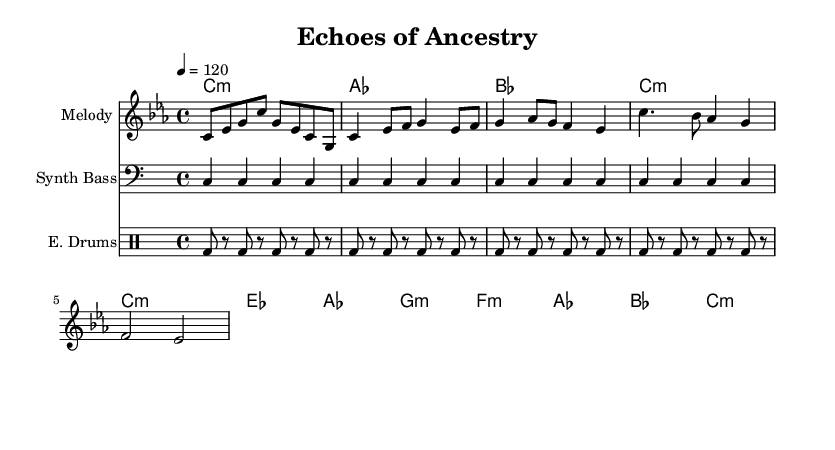What is the key signature of this music? The key signature is C minor, which has three flats (B flat, E flat, and A flat). This can be identified from the key signature notation at the beginning of the staff.
Answer: C minor What is the time signature of this music? The time signature is 4/4, which allows for four beats in each measure and is indicated at the beginning of the score. This means each measure can have four quarter note beats.
Answer: 4/4 What is the tempo marking of this piece? The tempo marking indicates a speed of 120 beats per minute, which is typical for dance music. It is notated as "4 = 120" in the tempo directive.
Answer: 120 How many measures are there in the melody section? The melody section consists of ten measures in total when counting both the intro, verse, and chorus parts that are labeled and follow the different sections.
Answer: 10 Which instrument plays the synth bass? The synth bass is indicated to be played in the bass clef on the second staff, marked as "Synth Bass."
Answer: Synth Bass In which sections are electronic drums used? Electronic drums are used throughout the entire piece including the intro, verse, and chorus sections as indicated by the consistent repetition in the drum staff.
Answer: All sections What type of harmony is used in the chorus? The chorus features minor harmonies as indicated with the chords, particularly the F minor, A flat, and B flat chords throughout this section.
Answer: Minor harmonies 